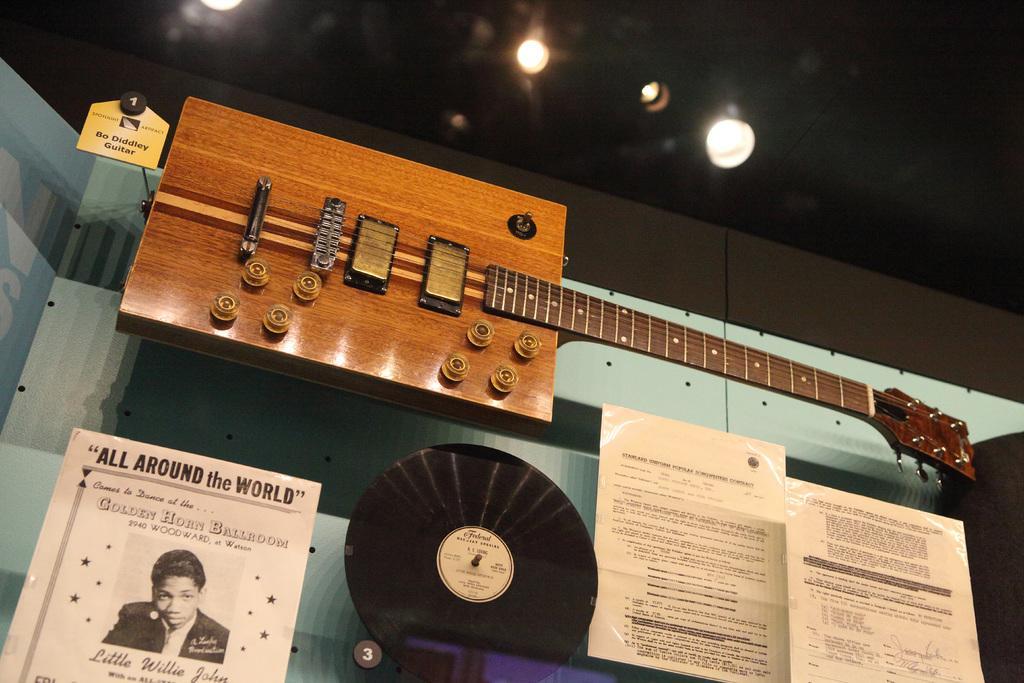Could you give a brief overview of what you see in this image? Here we can see guitar,poster and papers attached on glass. Top we can see lights. 